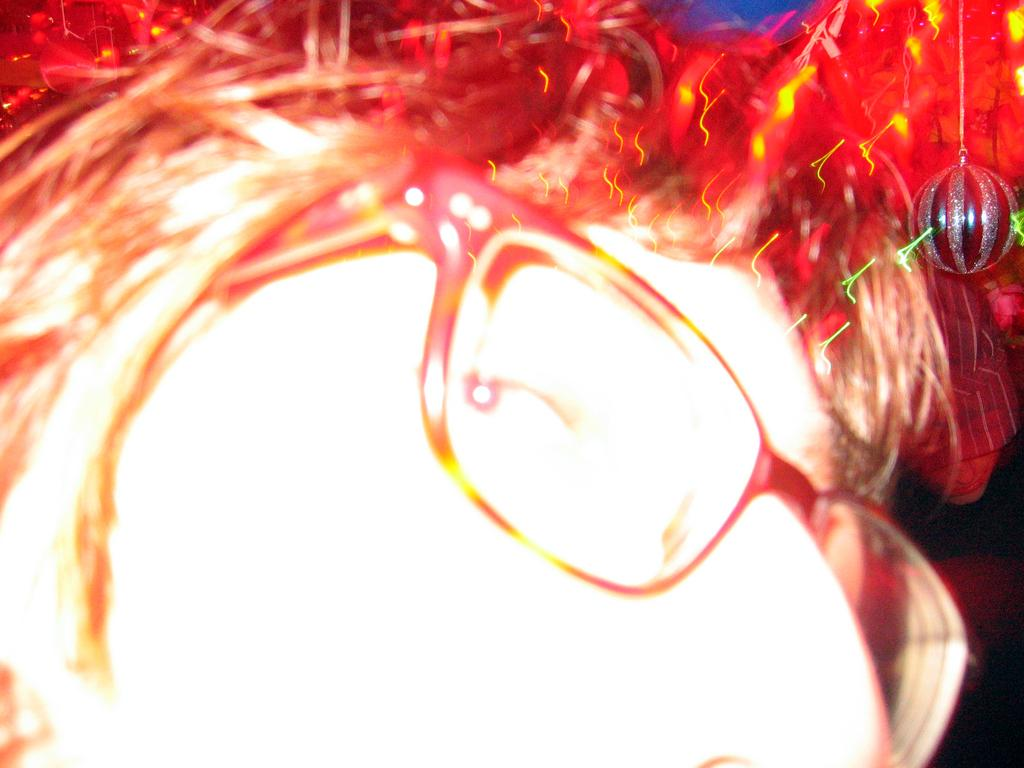What is the focus of the image? The image is zoomed in on the face of a person. Can you describe the person's face in the image? Unfortunately, the image is too zoomed in to provide a detailed description of the person's face. How many cattle can be seen grazing in the background of the image? There are no cattle visible in the image, as it is focused solely on the face of a person. 